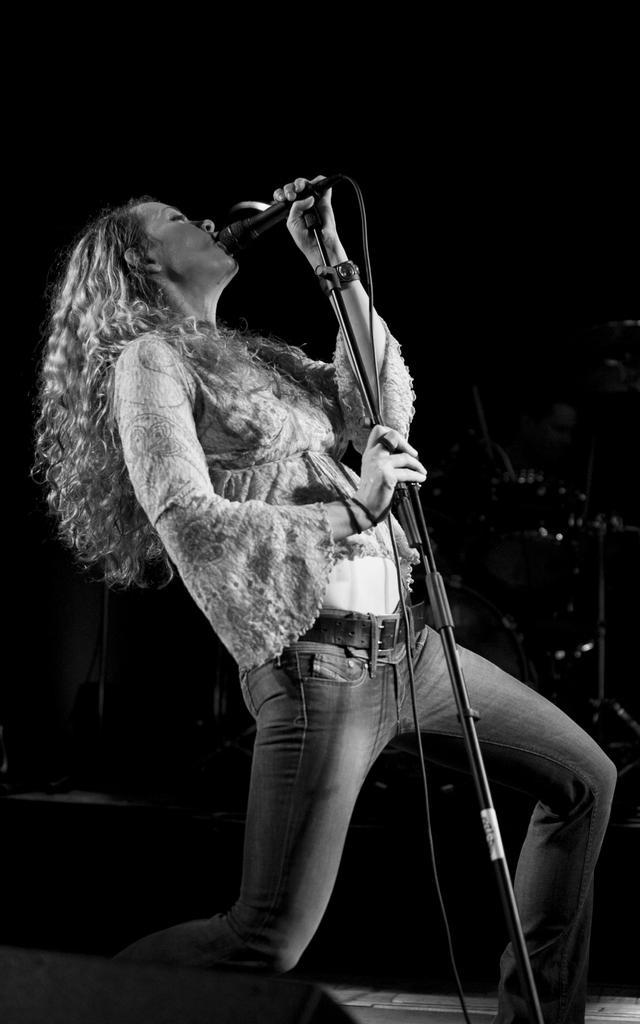Please provide a concise description of this image. In this picture we can see woman holding mic with her hand and singing and in background it is dark. 